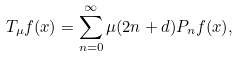<formula> <loc_0><loc_0><loc_500><loc_500>T _ { \mu } f ( x ) = \sum _ { n = 0 } ^ { \infty } \mu ( 2 n + d ) P _ { n } f ( x ) ,</formula> 